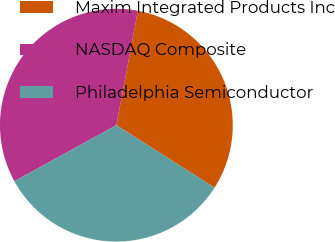Convert chart to OTSL. <chart><loc_0><loc_0><loc_500><loc_500><pie_chart><fcel>Maxim Integrated Products Inc<fcel>NASDAQ Composite<fcel>Philadelphia Semiconductor<nl><fcel>31.06%<fcel>35.96%<fcel>32.98%<nl></chart> 